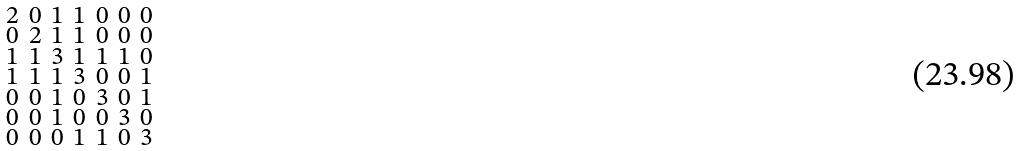<formula> <loc_0><loc_0><loc_500><loc_500>\begin{smallmatrix} 2 & 0 & 1 & 1 & 0 & 0 & 0 \\ 0 & 2 & 1 & 1 & 0 & 0 & 0 \\ 1 & 1 & 3 & 1 & 1 & 1 & 0 \\ 1 & 1 & 1 & 3 & 0 & 0 & 1 \\ 0 & 0 & 1 & 0 & 3 & 0 & 1 \\ 0 & 0 & 1 & 0 & 0 & 3 & 0 \\ 0 & 0 & 0 & 1 & 1 & 0 & 3 \end{smallmatrix}</formula> 